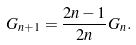Convert formula to latex. <formula><loc_0><loc_0><loc_500><loc_500>G _ { n + 1 } = \frac { 2 n - 1 } { 2 n } G _ { n } .</formula> 